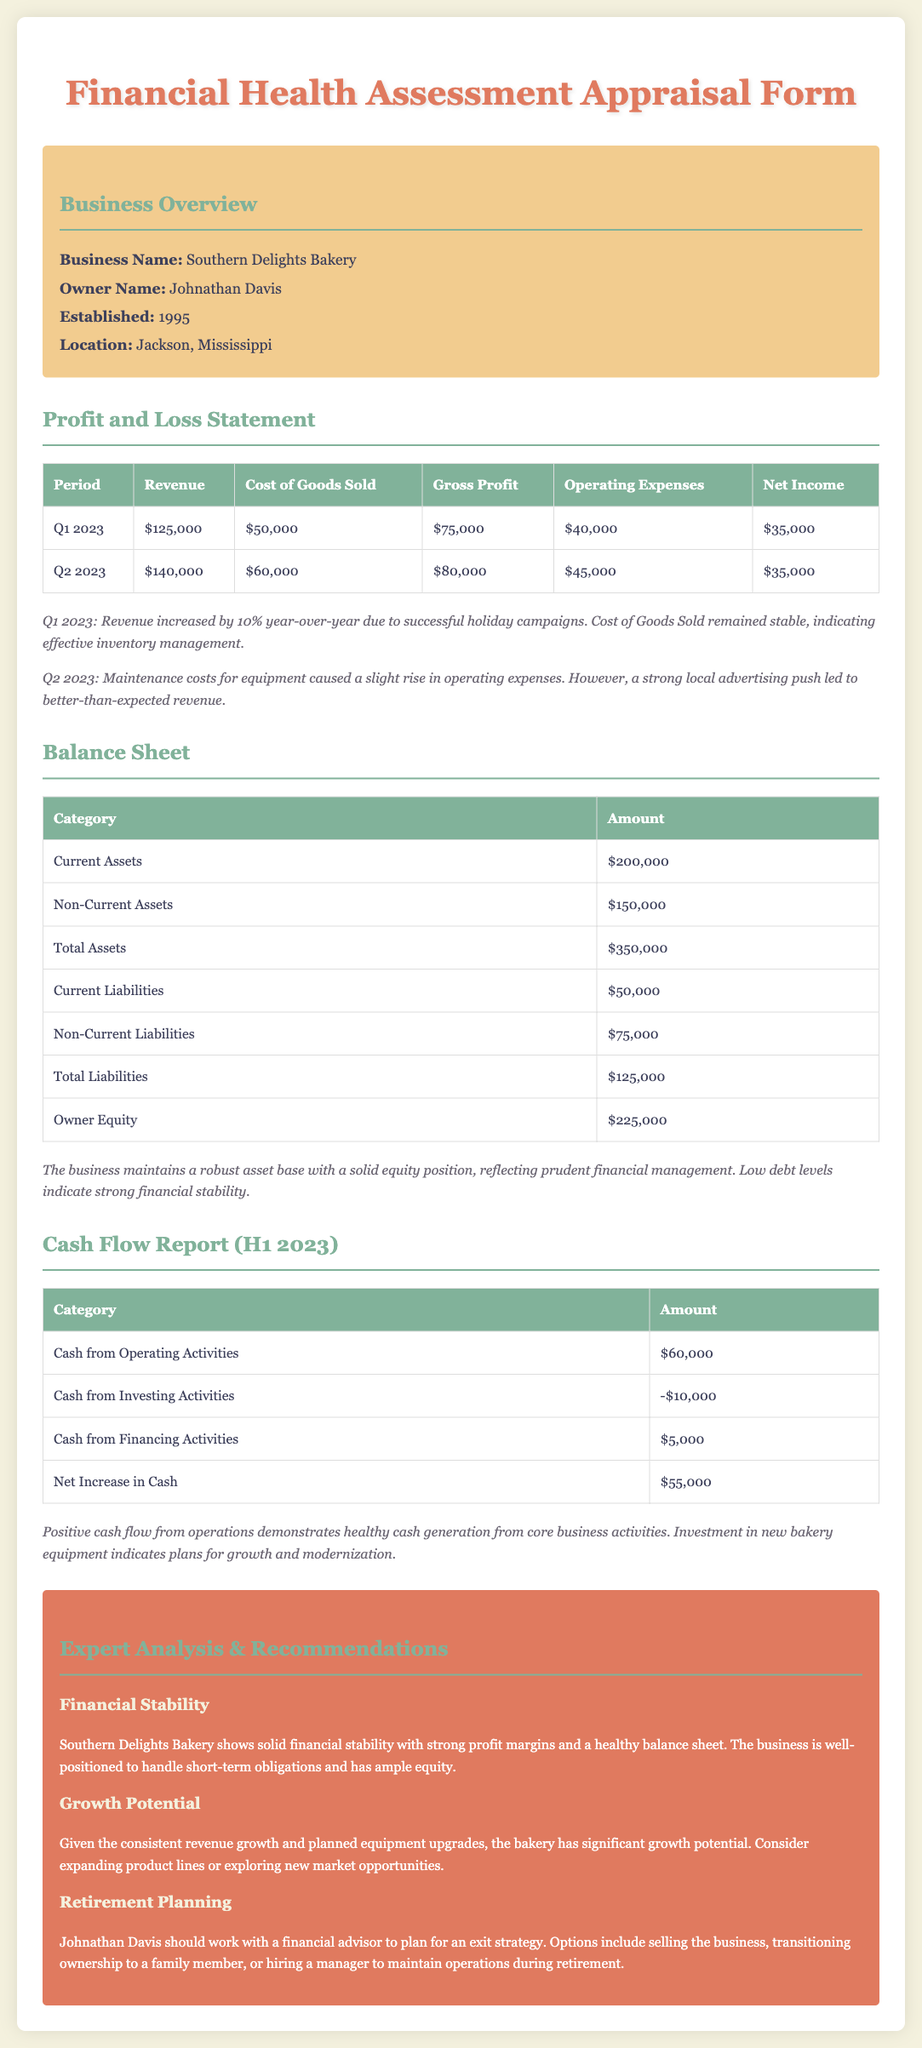What is the business name? The business name is stated in the business overview section of the document.
Answer: Southern Delights Bakery What is the owner's name? The owner's name is provided in the business overview section of the document.
Answer: Johnathan Davis What was the net income for Q2 2023? The net income for Q2 2023 is shown in the profit and loss statement.
Answer: $35,000 What are the current assets? The current assets are listed in the balance sheet of the document.
Answer: $200,000 What was the cash from investing activities for H1 2023? The cash from investing activities is reported in the cash flow report.
Answer: -$10,000 How much total liabilities does the business have? Total liabilities can be calculated from the balance sheet data provided.
Answer: $125,000 What year was the business established? The establishment year is mentioned in the business overview section.
Answer: 1995 What is recommended for retirement planning? The recommendations section discusses retirement planning strategies for the owner.
Answer: Work with a financial advisor What was the gross profit for Q1 2023? This information is detailed in the profit and loss statement of the document.
Answer: $75,000 How is the financial health of the business described? The financial health summary is provided in the expert analysis section.
Answer: Solid financial stability 